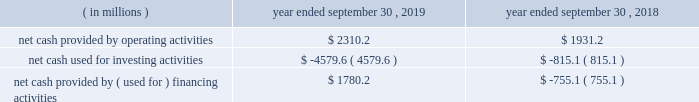Credit facilities .
As such , our foreign cash and cash equivalents are not expected to be a key source of liquidity to our domestic operations .
At september 30 , 2019 , we had approximately $ 2.9 billion of availability under our committed credit facilities , primarily under our revolving credit facility , the majority of which matures on july 1 , 2022 .
This liquidity may be used to provide for ongoing working capital needs and for other general corporate purposes , including acquisitions , dividends and stock repurchases .
Certain restrictive covenants govern our maximum availability under the credit facilities .
We test and report our compliance with these covenants as required and we were in compliance with all of these covenants at september 30 , 2019 .
At september 30 , 2019 , we had $ 129.8 million of outstanding letters of credit not drawn cash and cash equivalents were $ 151.6 million at september 30 , 2019 and $ 636.8 million at september 30 , 2018 .
We used a significant portion of the cash and cash equivalents on hand at september 30 , 2018 in connection with the closing of the kapstone acquisition .
Primarily all of the cash and cash equivalents at september 30 , 2019 were held outside of the u.s .
At september 30 , 2019 , total debt was $ 10063.4 million , $ 561.1 million of which was current .
At september 30 , 2018 , total debt was $ 6415.2 million , $ 740.7 million of which was current .
The increase in debt was primarily related to the kapstone acquisition .
Cash flow activity .
Net cash provided by operating activities during fiscal 2019 increased $ 379.0 million from fiscal 2018 primarily due to higher cash earnings and a $ 340.3 million net decrease in the use of working capital compared to the prior year .
As a result of the retrospective adoption of asu 2016-15 and asu 2016-18 ( each as hereinafter defined ) as discussed in 201cnote 1 .
Description of business and summary of significant accounting policies 201d of the notes to consolidated financial statements , net cash provided by operating activities for fiscal 2018 was reduced by $ 489.7 million and cash provided by investing activities increased $ 483.8 million , primarily for the change in classification of proceeds received for beneficial interests obtained for transferring trade receivables in securitization transactions .
Net cash used for investing activities of $ 4579.6 million in fiscal 2019 consisted primarily of $ 3374.2 million for cash paid for the purchase of businesses , net of cash acquired ( excluding the assumption of debt ) , primarily related to the kapstone acquisition , and $ 1369.1 million for capital expenditures that were partially offset by $ 119.1 million of proceeds from the sale of property , plant and equipment primarily related to the sale of our atlanta beverage facility , $ 33.2 million of proceeds from corporate owned life insurance benefits and $ 25.5 million of proceeds from property , plant and equipment insurance proceeds related to the panama city , fl mill .
Net cash used for investing activities of $ 815.1 million in fiscal 2018 consisted primarily of $ 999.9 million for capital expenditures , $ 239.9 million for cash paid for the purchase of businesses , net of cash acquired primarily related to the plymouth acquisition and the schl fcter acquisition , and $ 108.0 million for an investment in grupo gondi .
These investments were partially offset by $ 461.6 million of cash receipts on sold trade receivables as a result of the adoption of asu 2016-15 , $ 24.0 million of proceeds from the sale of certain affiliates as well as our solid waste management brokerage services business and $ 23.3 million of proceeds from the sale of property , plant and equipment .
In fiscal 2019 , net cash provided by financing activities of $ 1780.2 million consisted primarily of a net increase in debt of $ 2314.6 million , primarily related to the kapstone acquisition and partially offset by cash dividends paid to stockholders of $ 467.9 million and purchases of common stock of $ 88.6 million .
In fiscal 2018 , net cash used for financing activities of $ 755.1 million consisted primarily of cash dividends paid to stockholders of $ 440.9 million and purchases of common stock of $ 195.1 million and net repayments of debt of $ 120.1 million. .
What percent of the cash used for investing activities was used for the purchase of businesses? 
Computations: (3374.2 / 4579.6)
Answer: 0.73679. 